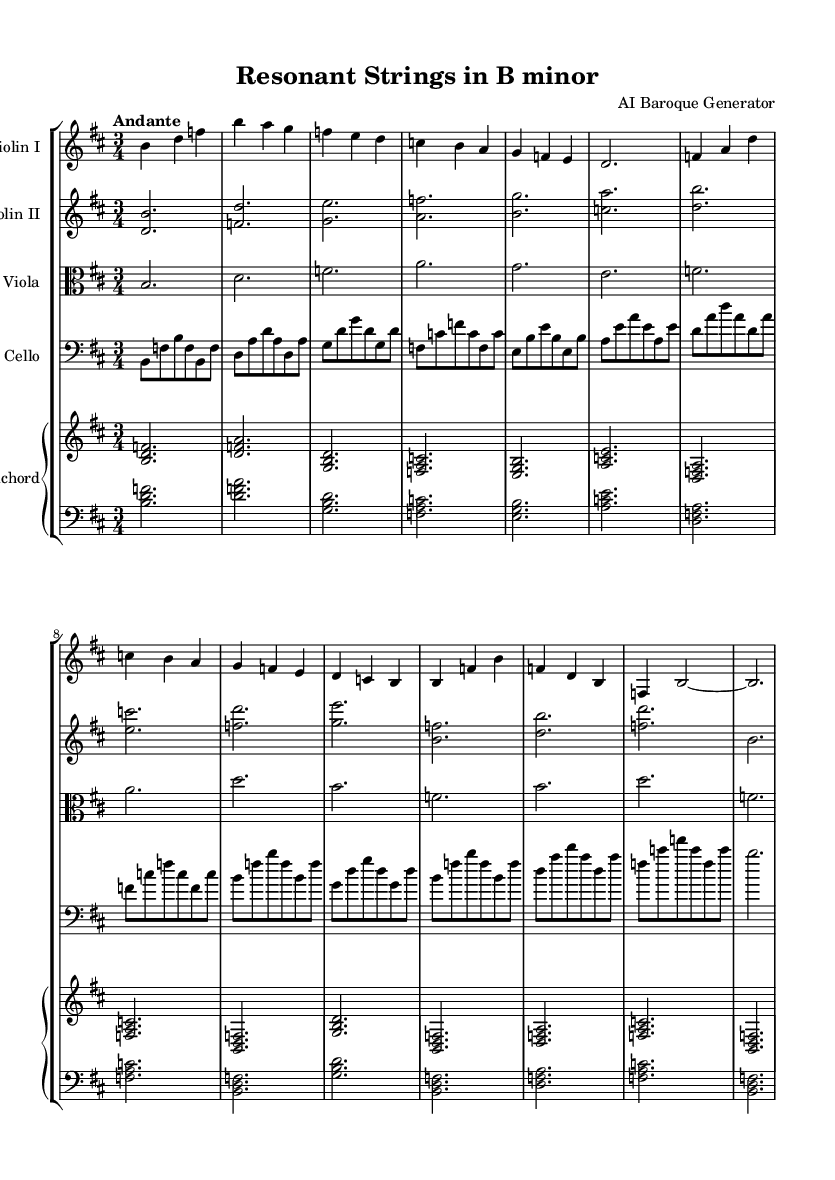What is the key signature of this music? The key signature has two sharps, which indicate that the piece is in B minor. It is visible at the beginning of the staves, showing the sharps on F and C lines.
Answer: B minor What is the time signature of this music? The time signature displayed at the beginning of the score is 3/4, which shows that there are three beats in a measure and a quarter note receives one beat.
Answer: 3/4 What is the tempo marking of this music? The tempo marking "Andante" indicates a moderate tempo, often interpreted as walking pace. This marking is placed above the staff at the beginning of the score.
Answer: Andante How many measures are in Section A? Section A contains eight measures, which can be counted from the start of the violin I part until the end of the specified section.
Answer: 8 Which instrument plays double stops? The violin II part is where the double stops occur, as indicated by the notation showing two notes played simultaneously.
Answer: Violin II What rhythmic pattern is predominant in the cello part? The cello part primarily features arpeggiated figures, characterized by broken chords where the notes are played in succession rather than simultaneously. This can be observed throughout its part.
Answer: Arpeggiated figures What role does the harpsichord play in this composition? The harpsichord serves as the continuo, providing harmonic support and filling the texture by playing chords that accompany the melodic instruments. This is evident in its part's chordal structure.
Answer: Continuo 